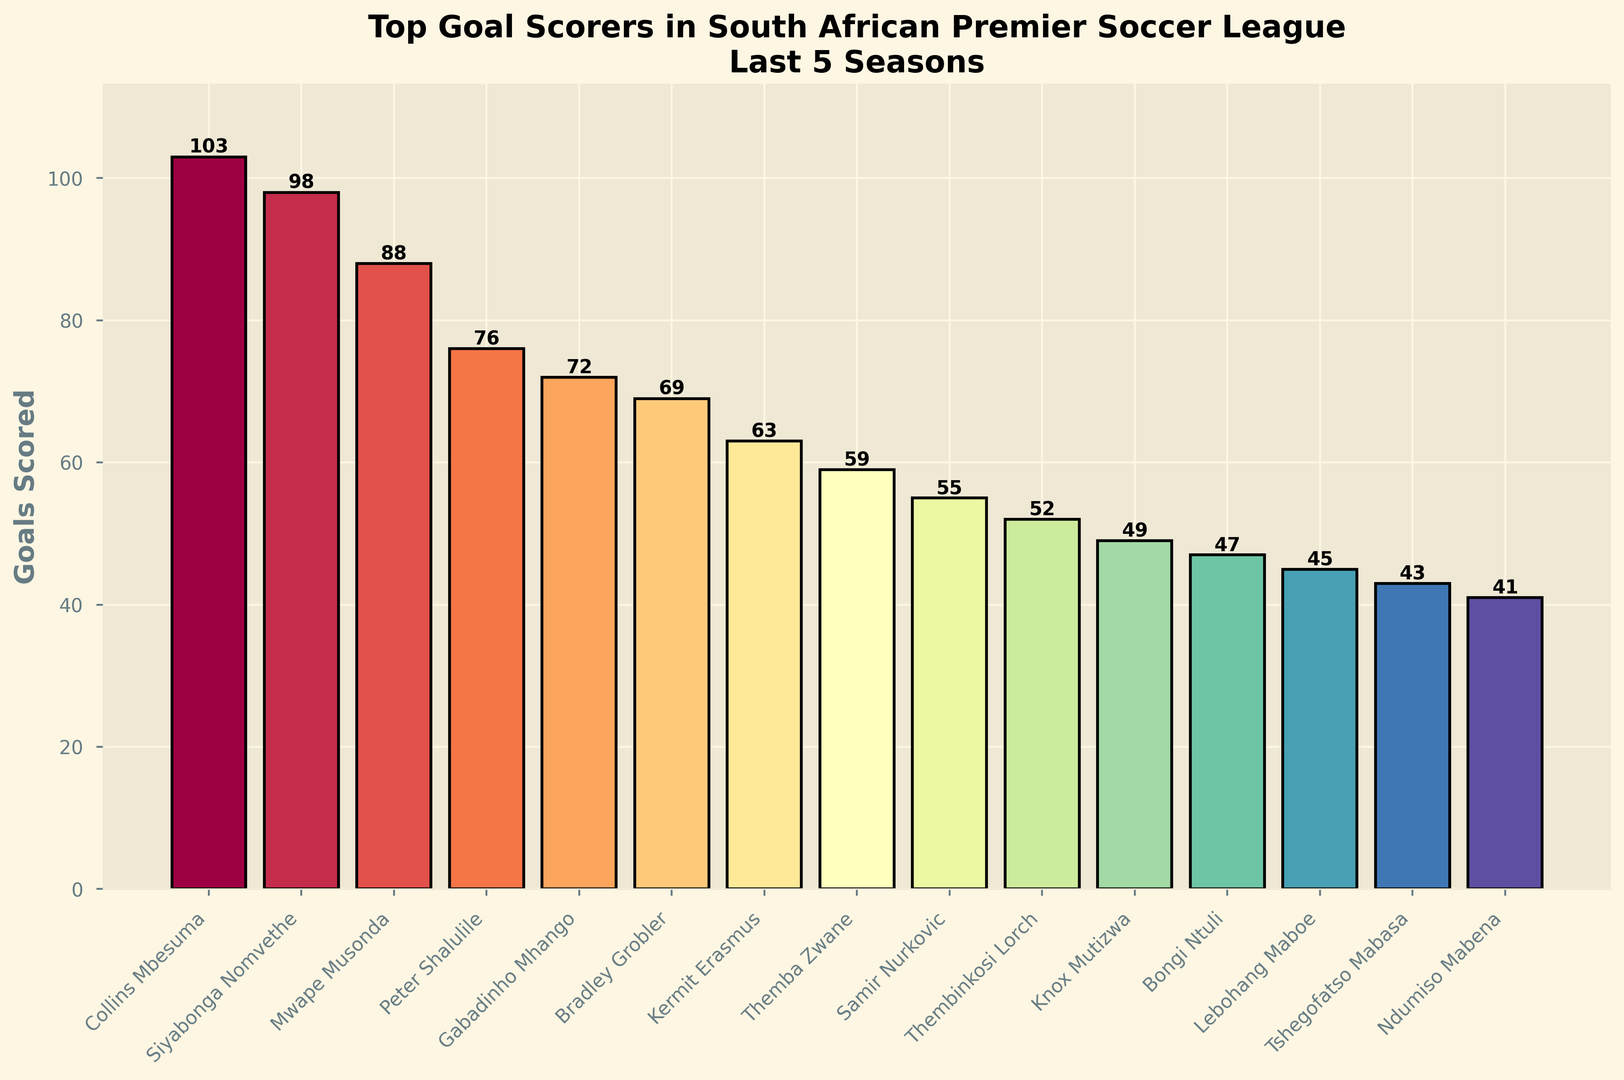Which player scored the most goals? Look at the bar representing each player and identify the tallest bar. The tallest bar is for Collins Mbesuma, indicating he scored the most goals.
Answer: Collins Mbesuma How many goals did Collins Mbesuma and Siyabonga Nomvethe score combined? Find Collins Mbesuma's and Siyabonga Nomvethe's bars. Mbesuma scored 103 goals, and Nomvethe scored 98. Add these two values: 103 + 98 = 201.
Answer: 201 Who scored more goals: Gabadinho Mhango or Bradley Grobler? Compare the heights of the bars for Gabadinho Mhango and Bradley Grobler. Mhango's bar is taller, indicating he scored more goals.
Answer: Gabadinho Mhango What is the difference in goals scored between Peter Shalulile and Thembinkosi Lorch? Identify the bars for Peter Shalulile and Thembinkosi Lorch. Shalulile scored 76 goals and Lorch scored 52. Subtract Lorch's total from Shalulile's: 76 - 52 = 24.
Answer: 24 How many players scored more than 60 goals? Count the number of bars whose height is greater than the line representing 60 goals. Collins Mbesuma, Siyabonga Nomvethe, Mwape Musonda, Peter Shalulile, Gabadinho Mhango, and Bradley Grobler each scored more than 60 goals. So there are 6 players.
Answer: 6 What is the average number of goals scored by the top 5 goal-scorers? Identify the top 5 goal-scorers and their goals: Collins Mbesuma (103), Siyabonga Nomvethe (98), Mwape Musonda (88), Peter Shalulile (76), Gabadinho Mhango (72). Sum these values and divide by 5: (103 + 98 + 88 + 76 + 72) / 5 = 437 / 5 = 87.4.
Answer: 87.4 Who scored the least goals among the top 15 scorers? Look for the shortest bar among all the bars presented. Ndumiso Mabena's bar is the shortest, indicating he scored the least goals.
Answer: Ndumiso Mabena Is the difference in goals scored between them higher than 50 for Collins Mbesuma and Themba Zwane? Identify the bars for Collins Mbesuma and Themba Zwane. Mbesuma scored 103 goals, and Zwane scored 59. The difference is 103 - 59 = 44, which is less than 50.
Answer: No, it's less than 50 